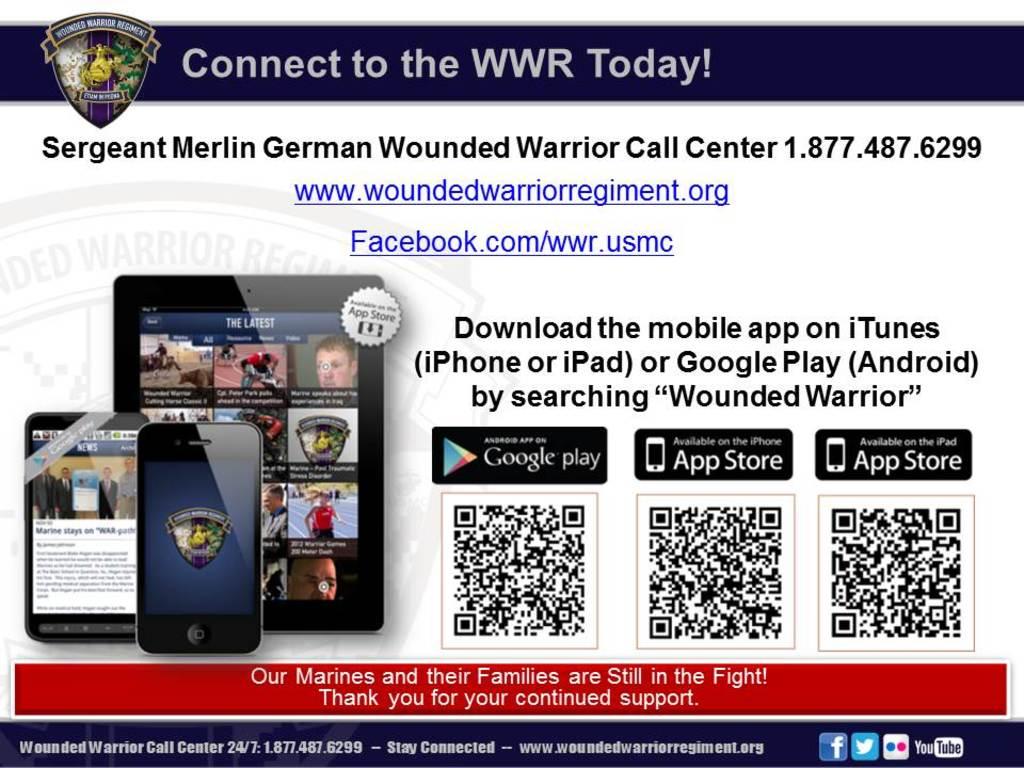What are we connecting to?
Provide a succinct answer. Wwr. What is the website address provided?
Keep it short and to the point. Www.woundedwarriorregiment.org. 